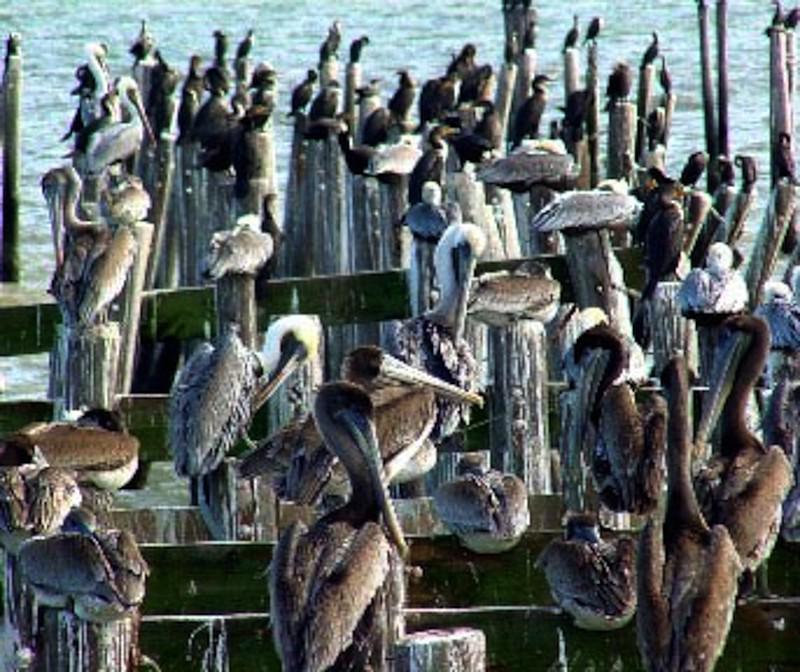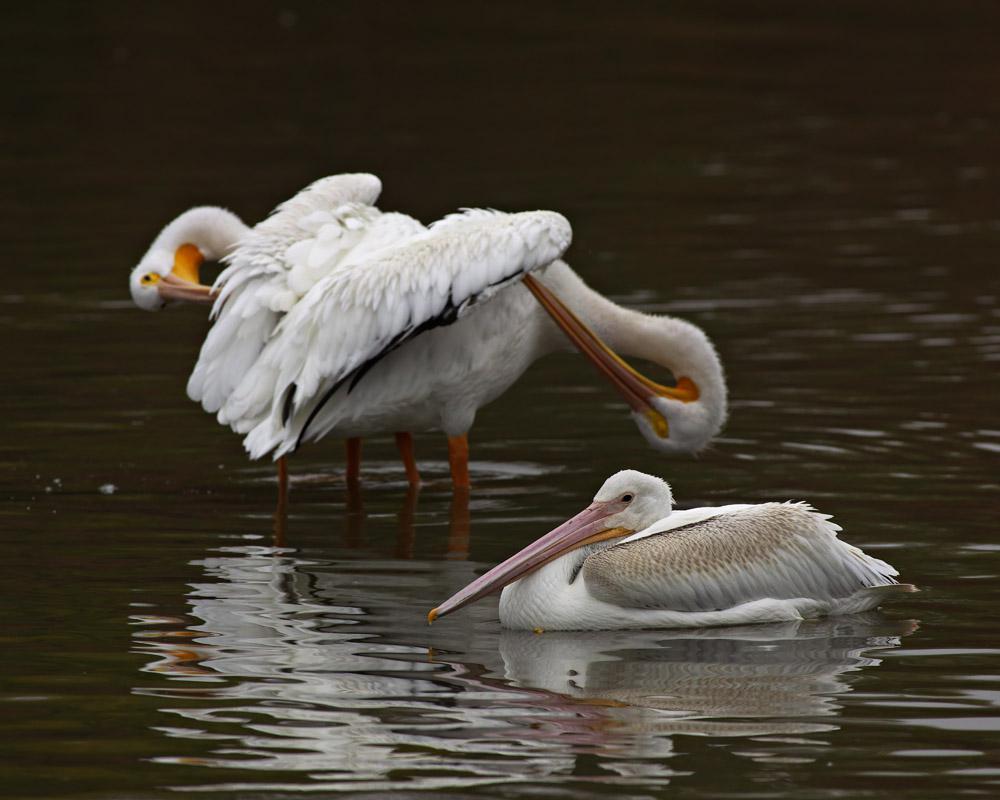The first image is the image on the left, the second image is the image on the right. Evaluate the accuracy of this statement regarding the images: "In one image, there is at least one person near a pelican.". Is it true? Answer yes or no. No. The first image is the image on the left, the second image is the image on the right. Examine the images to the left and right. Is the description "At least one person is interacting with birds in one image." accurate? Answer yes or no. No. 